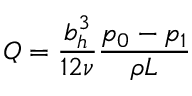<formula> <loc_0><loc_0><loc_500><loc_500>Q = \frac { b _ { h } ^ { 3 } } { 1 2 \nu } \frac { p _ { 0 } - p _ { 1 } } { \rho L }</formula> 